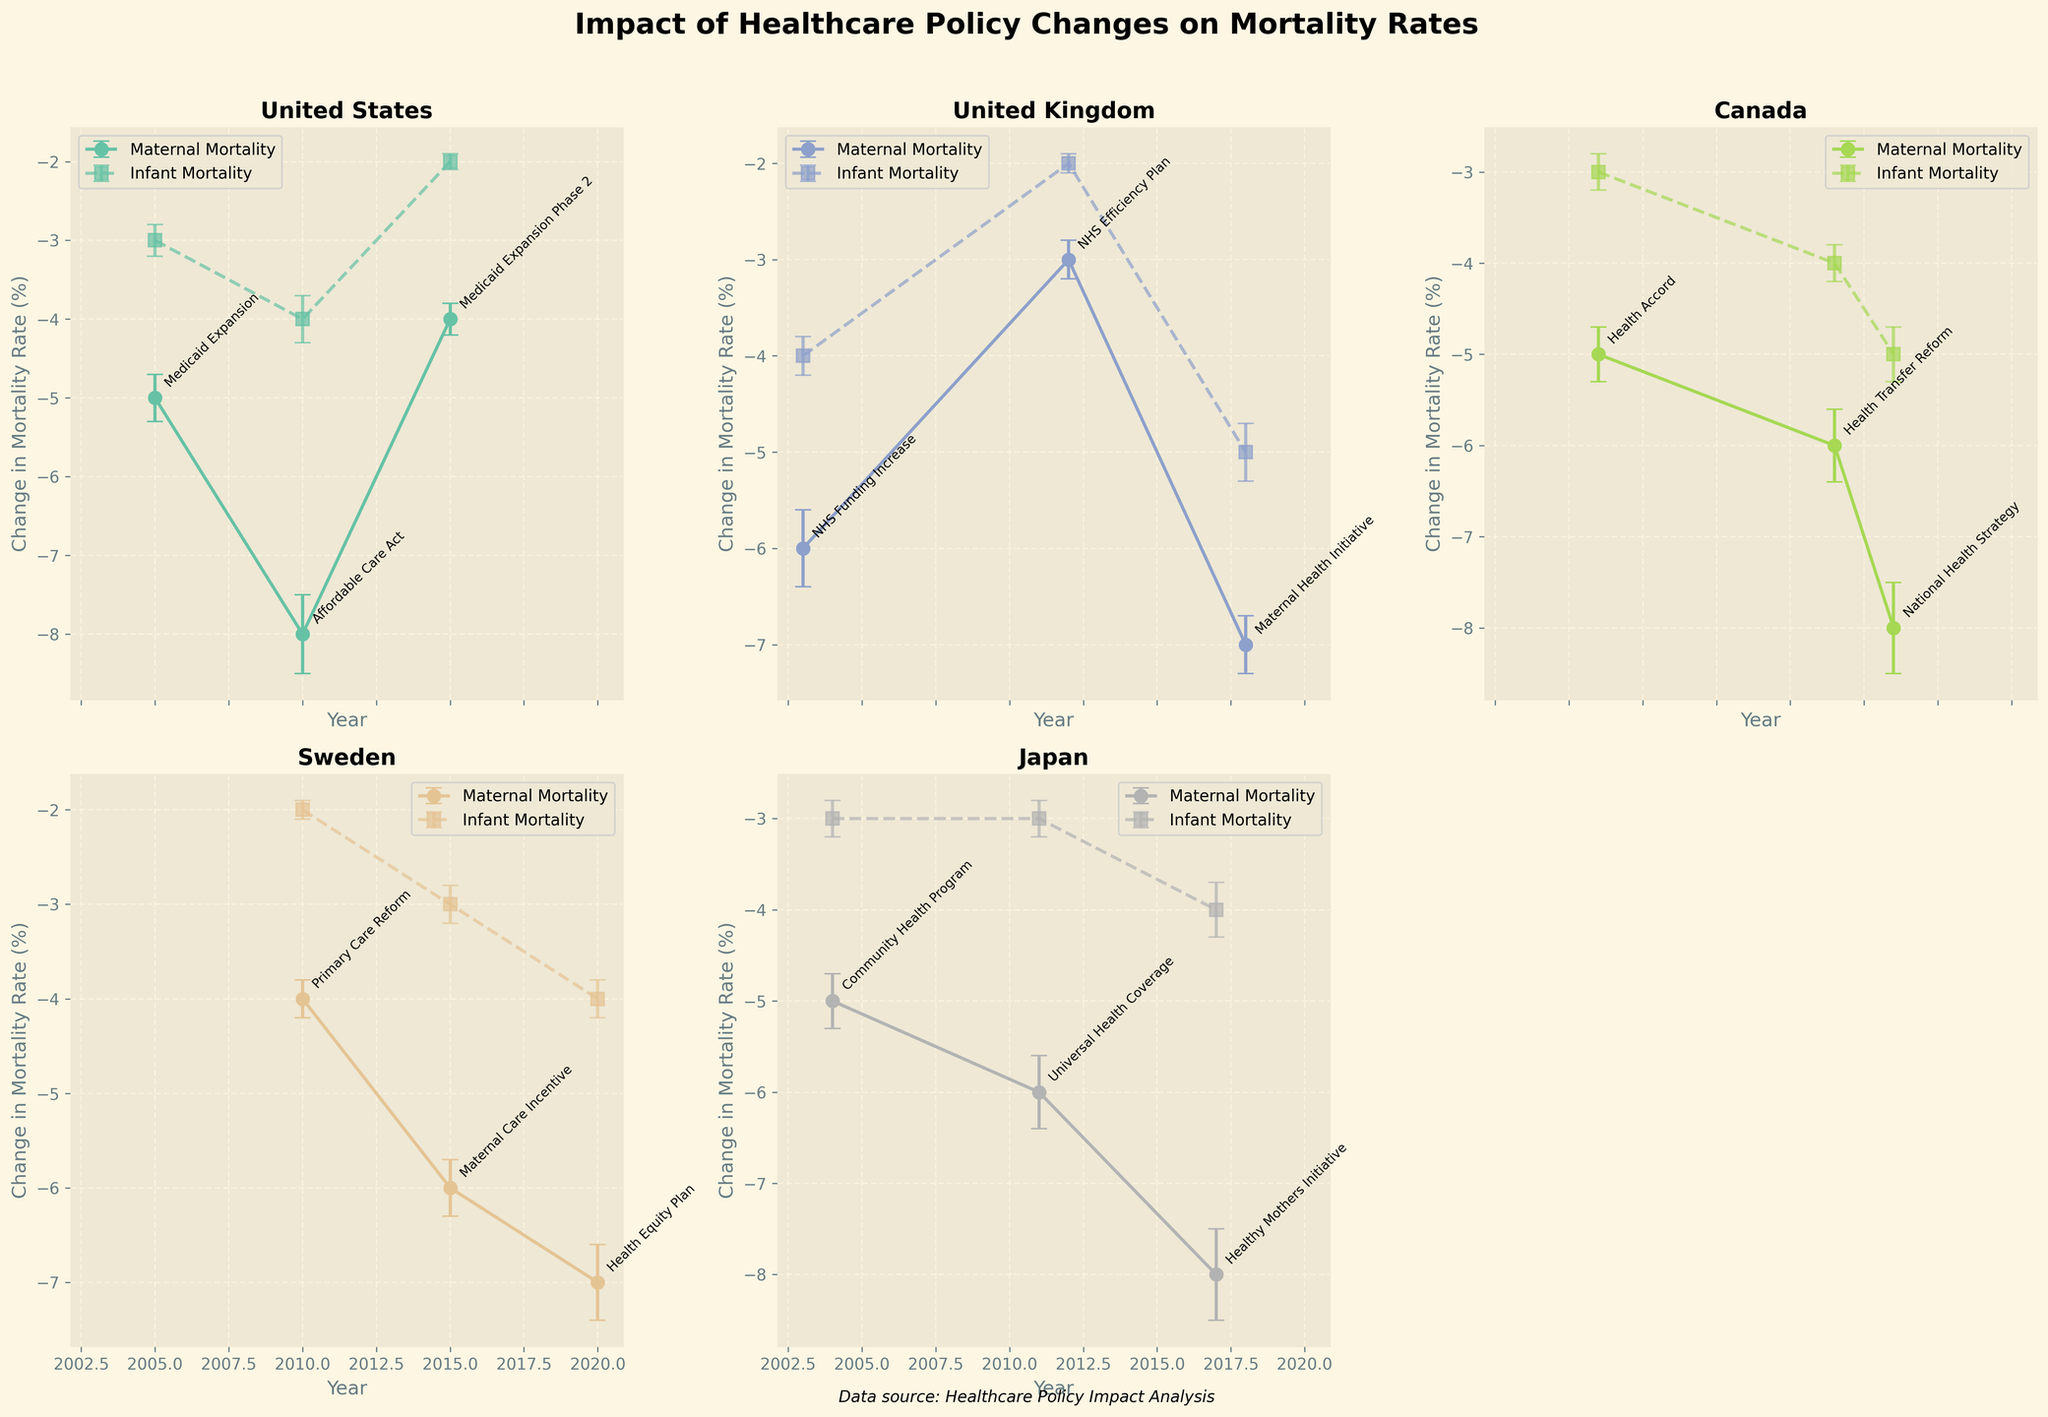What is the title of the figure? The title is located at the top center of the figure and summarizes the main focus of the data presentation. It reads, "Impact of Healthcare Policy Changes on Mortality Rates."
Answer: Impact of Healthcare Policy Changes on Mortality Rates How many countries are featured in the figure? Each subplot represents a different country. Counting the subplots reveals six countries.
Answer: Six Which country shows the largest decrease in maternal mortality rate (%) with the least error in the figure? By examining the subplots, Canada in 2016 with the National Health Strategy shows the largest decrease of -8% with a standard error of 0.5, matching with Japan in 2017 but less error than other lower values.
Answer: Japan (2017, Healthy Mothers Initiative) What is the impact of the "Affordable Care Act" on the maternal mortality rate (%) in the United States? The subplot for the United States indicates that the "Affordable Care Act" in 2010 led to a decrease of -8% in the maternal mortality rate.
Answer: -8% Which policy in the United Kingdom resulted in the highest reduction in infant mortality rate (%) and what was the value? Referring to the United Kingdom's subplot, the "Maternal Health Initiative" in 2018 resulted in the highest reduction with a value of -5%.
Answer: Maternal Health Initiative, -5% Compare the impact on maternal mortality rate (%) between “Primary Care Reform” in Sweden and “Health Equity Plan” in Sweden. Sweden’s subplot shows that the “Primary Care Reform” in 2010 reduced the maternal mortality rate by -4%, while the “Health Equity Plan” in 2020 reduced it by -7%.
Answer: Health Equity Plan (-7%) is greater than Primary Care Reform (-4%) What is the standard error for the change in infant mortality rate (%) for Canada in 2014? In Canada’s subplot, the “Health Transfer Reform” in 2014 shows a reduction in the infant mortality rate with a standard error of 0.2.
Answer: 0.2 Which policy had a greater impact on both maternal and infant mortality rates in Japan, "Universal Health Coverage" or "Healthy Mothers Initiative"? Comparing Japan’s subplot, the "Healthy Mothers Initiative" in 2017 had a greater impact on both maternal mortality (-8%) and infant mortality (-4%) compared to "Universal Health Coverage" in 2011 (-6% maternal, -3% infant).
Answer: Healthy Mothers Initiative What is the average decrease in maternal mortality rate (%) for the policies implemented in Sweden? The subplots reveal the following decreases in Sweden: -4% (2010), -6% (2015), -7% (2020). The average is calculated as (-4 + -6 + -7) / 3 = -17 / 3 = -5.67%.
Answer: -5.67% Which policy had the least impact on the maternal mortality rate (%) in the United Kingdom? The United Kingdom's subplot shows that the "NHS Efficiency Plan" in 2012 had the smallest impact, reducing the maternal mortality rate by only -3%.
Answer: NHS Efficiency Plan 